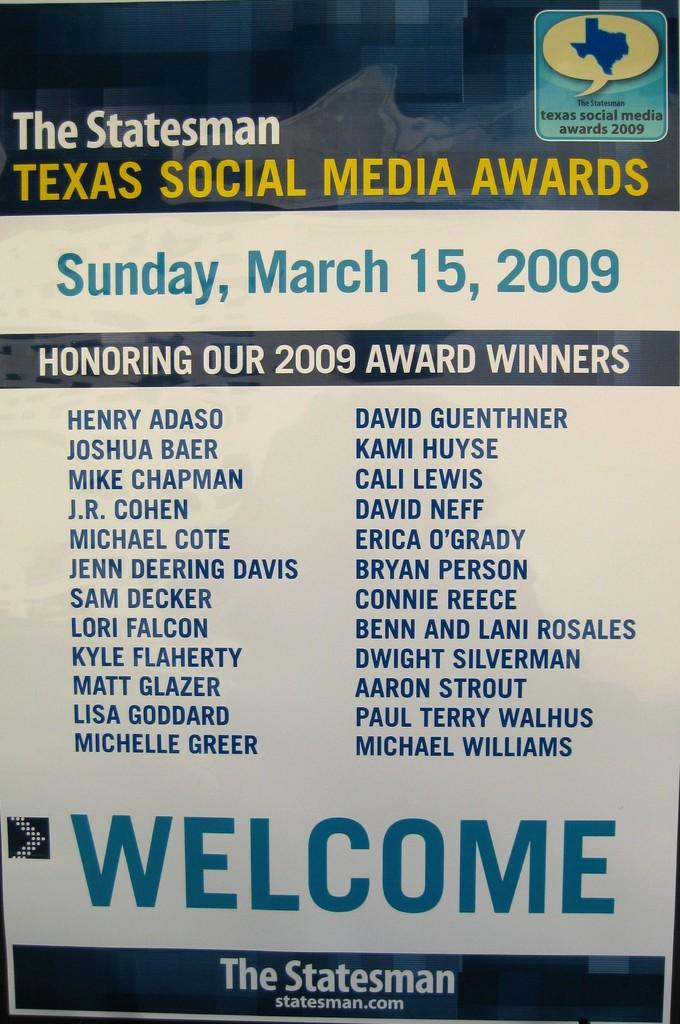<image>
Describe the image concisely. A poster for the Texas Social Media Awards lists two long columns of 2009 award winners. 